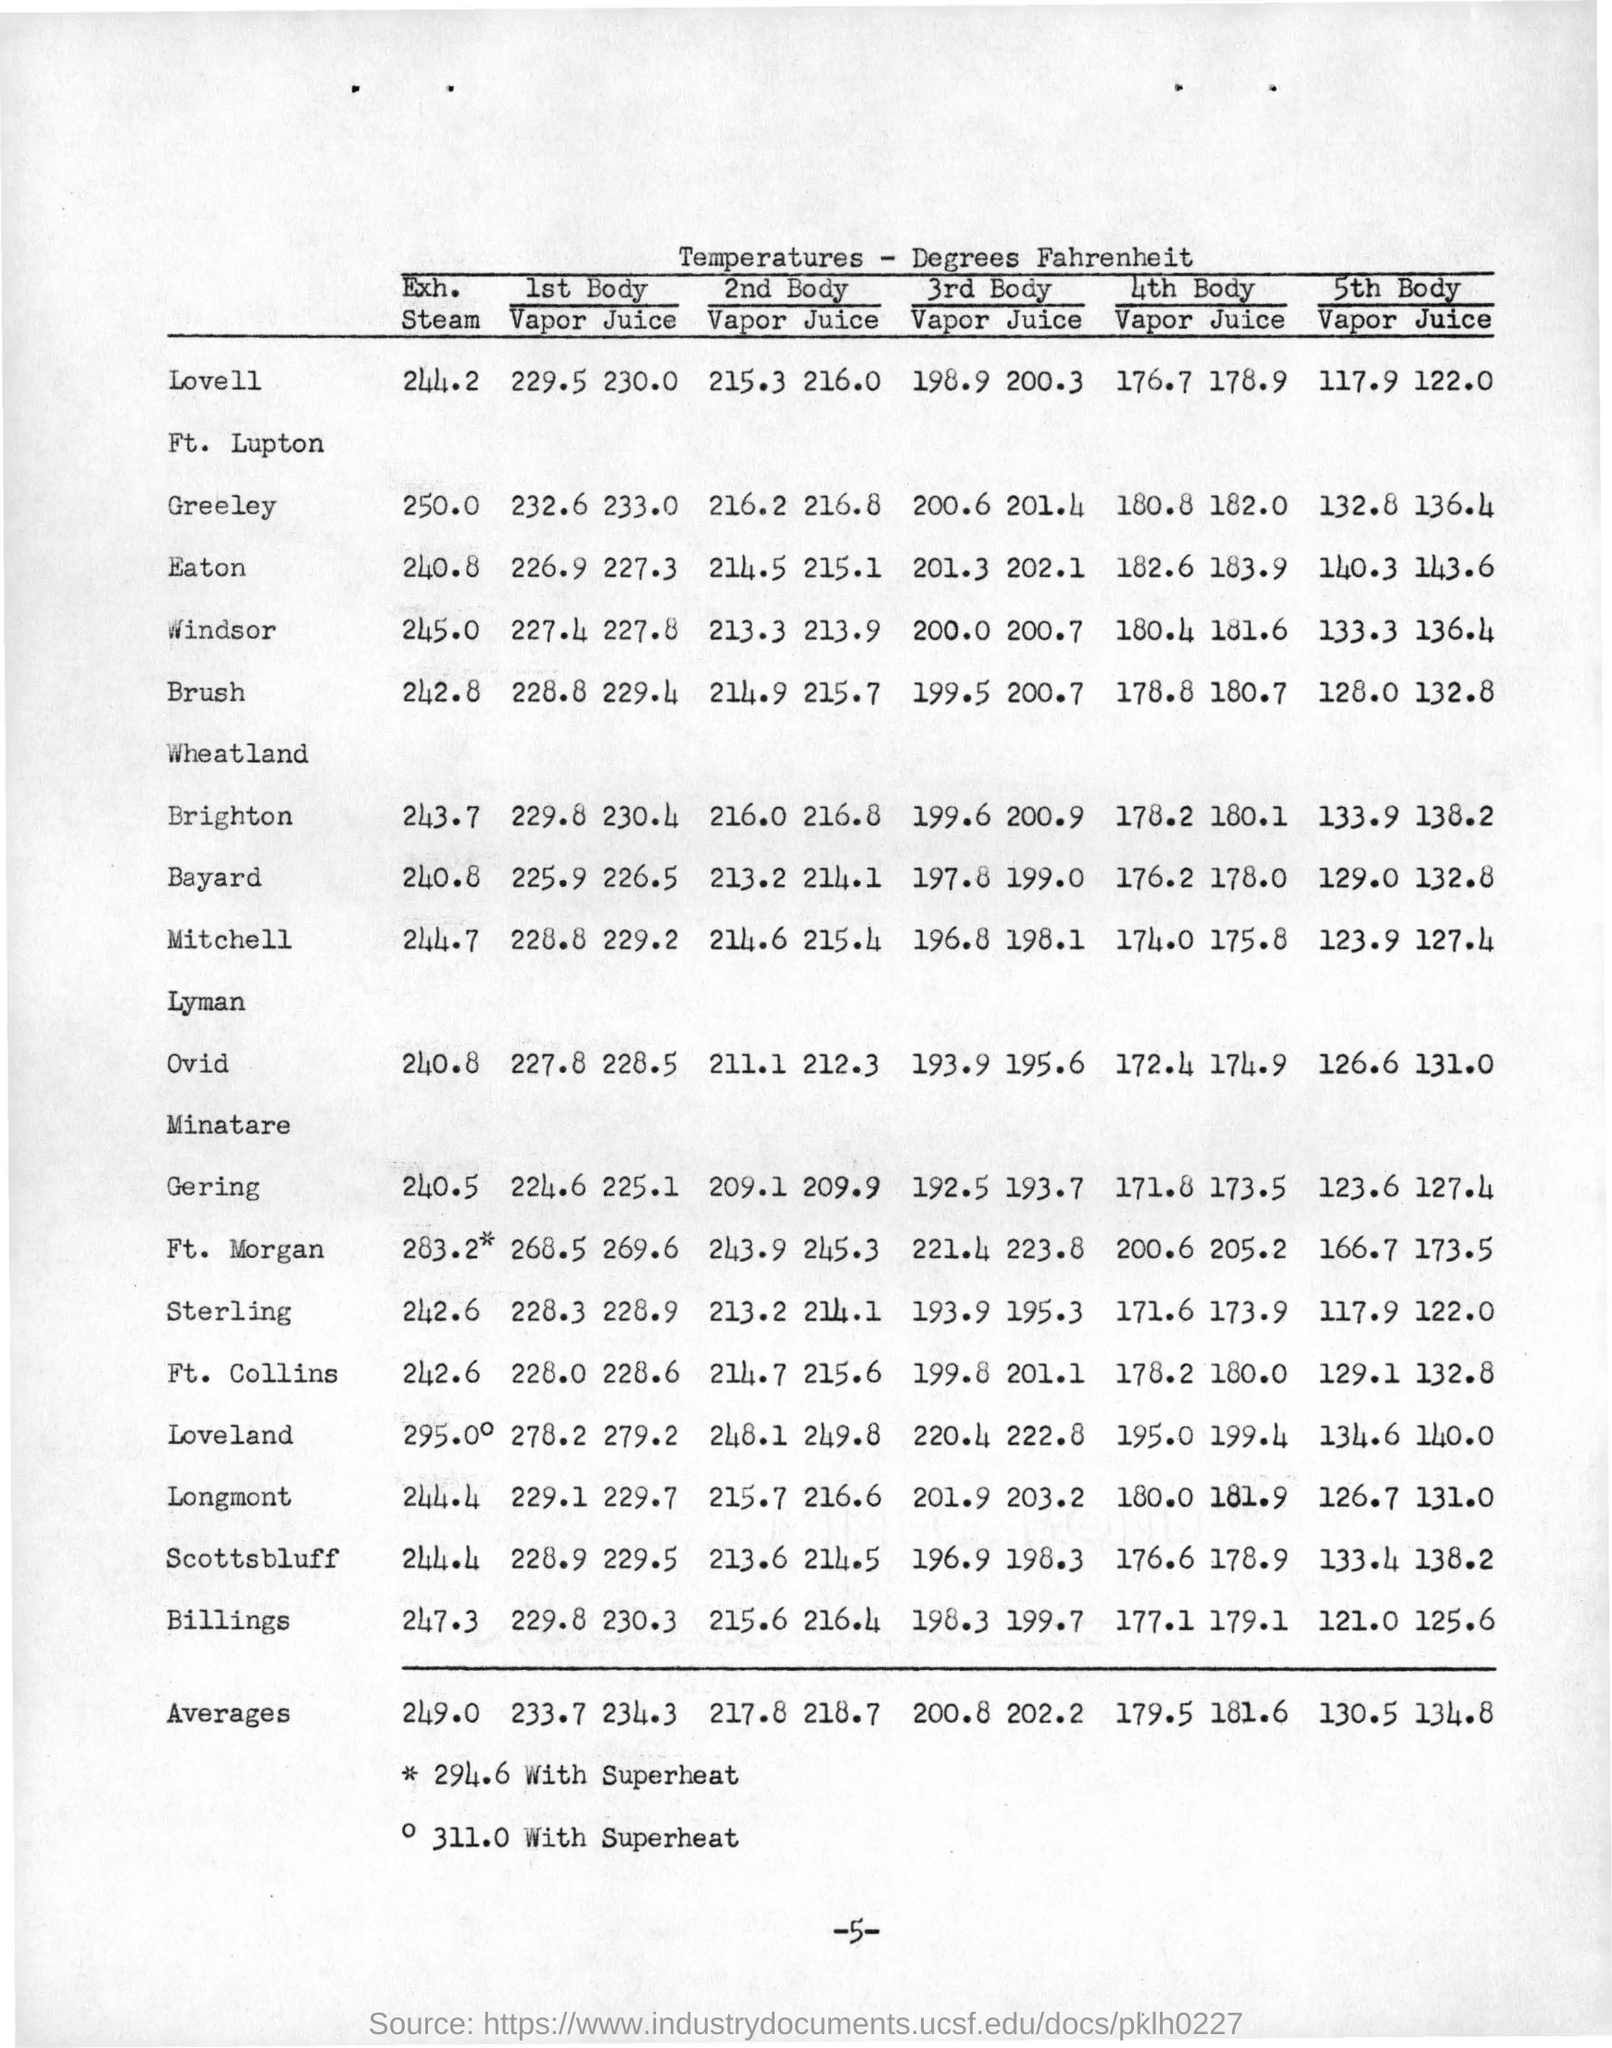What is the temperature of 1st body in vapor for windsor ?
Your answer should be very brief. 227.4. What is the temperature of 5th body in juice for bayard ?
Provide a succinct answer. 132.8. What is the average value of temperature for 2nd body in vapor
Your response must be concise. 217.8. What is the average temperature value for 4th body in juice ?
Ensure brevity in your answer.  181.6. What does *symbol indicate?
Your response must be concise. 294.6 with superheat. What does o symbol represents as per the table footnotes ?
Your response must be concise. 311.0 with Superheat. 